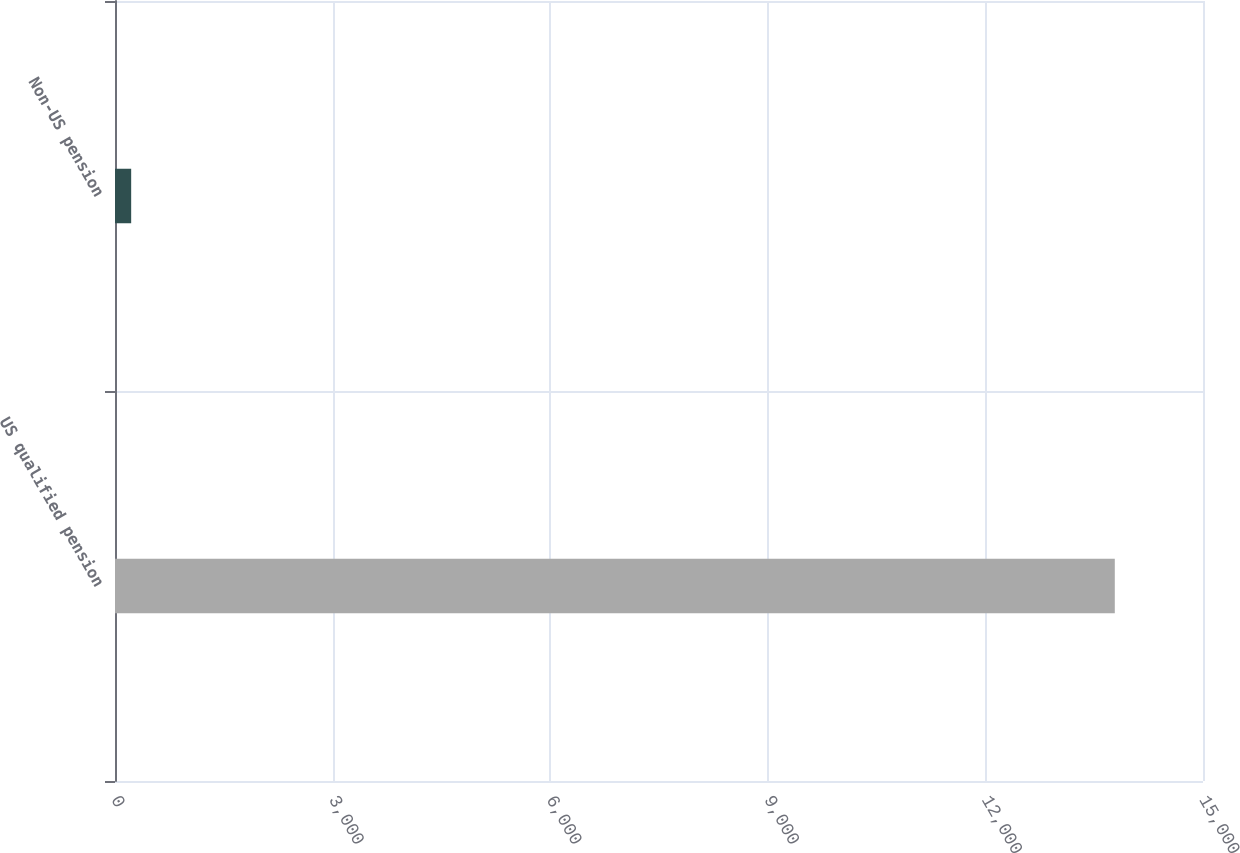Convert chart to OTSL. <chart><loc_0><loc_0><loc_500><loc_500><bar_chart><fcel>US qualified pension<fcel>Non-US pension<nl><fcel>13784<fcel>223<nl></chart> 